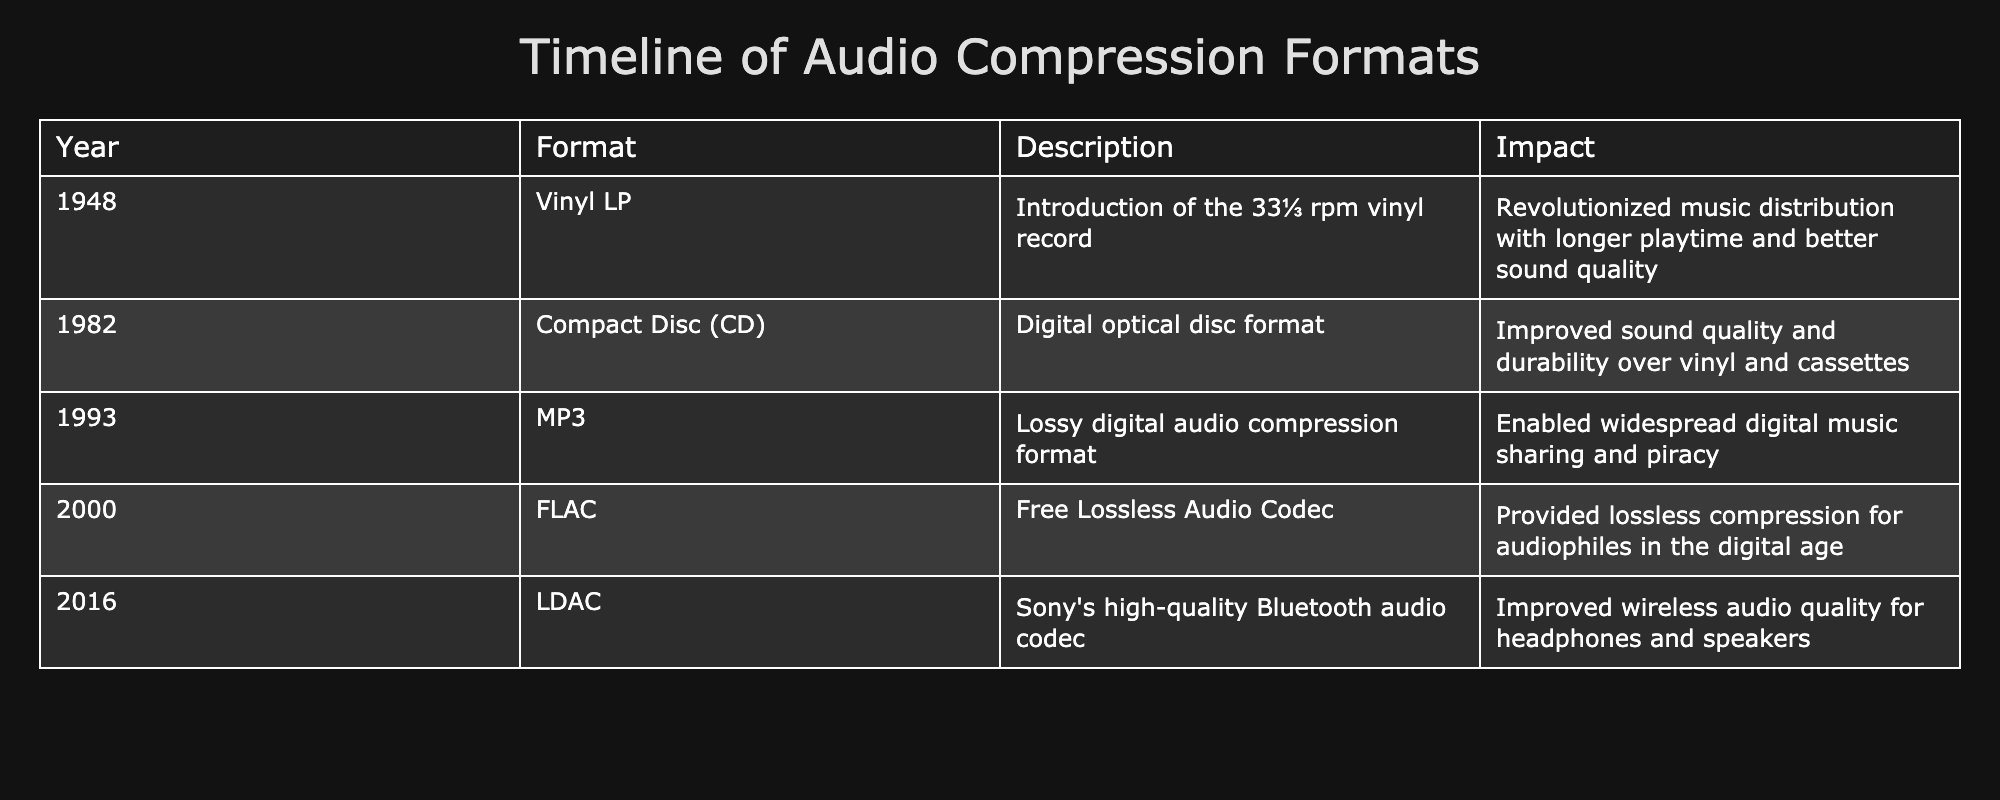What year was the Vinyl LP introduced? The table lists the Vinyl LP under the "Year" column, which indicates it was introduced in 1948.
Answer: 1948 What format succeeded the Compact Disc in popularity for music distribution? The table shows MP3 was introduced after the Compact Disc. This implies that MP3 succeeded it in popularity for music distribution.
Answer: MP3 Which formats mentioned in the table provide lossless compression? The relevant formats for lossless compression are FLAC, and since no other formats in the table mention lossless, the answer is only FLAC.
Answer: FLAC What is the difference in years between the introduction of the MP3 and FLAC formats? MP3 was introduced in 1993 and FLAC in 2000. The difference in years is calculated as 2000 - 1993 = 7 years.
Answer: 7 years Do any audio formats in the table have a specific mention of "better sound quality" compared to vinyl? Yes, the Compact Disc is specifically noted for having improved sound quality compared to vinyl and cassettes.
Answer: Yes Which format had the earliest introduction and what was its impact? The table indicates the Vinyl LP was introduced in 1948, and its impact was that it revolutionized music distribution by providing longer playtime and better sound quality.
Answer: Vinyl LP; revolutionized music distribution Which audio format was introduced most recently and what is its significance? The most recent format mentioned is LDAC, introduced in 2016, which is significant for improving wireless audio quality for headphones and speakers.
Answer: LDAC; improved wireless audio quality How many formats mentioned in the table focus on digital audio? From the table, MP3, FLAC, and LDAC focus on digital audio, amounting to 3 formats in total.
Answer: 3 formats What was the main characteristic of the MP3 format, and how did it impact music distribution? The MP3 format is a lossy digital audio compression format that enabled widespread digital music sharing and piracy, influencing how music was distributed digitally.
Answer: Lossy compression; widespread sharing and piracy 